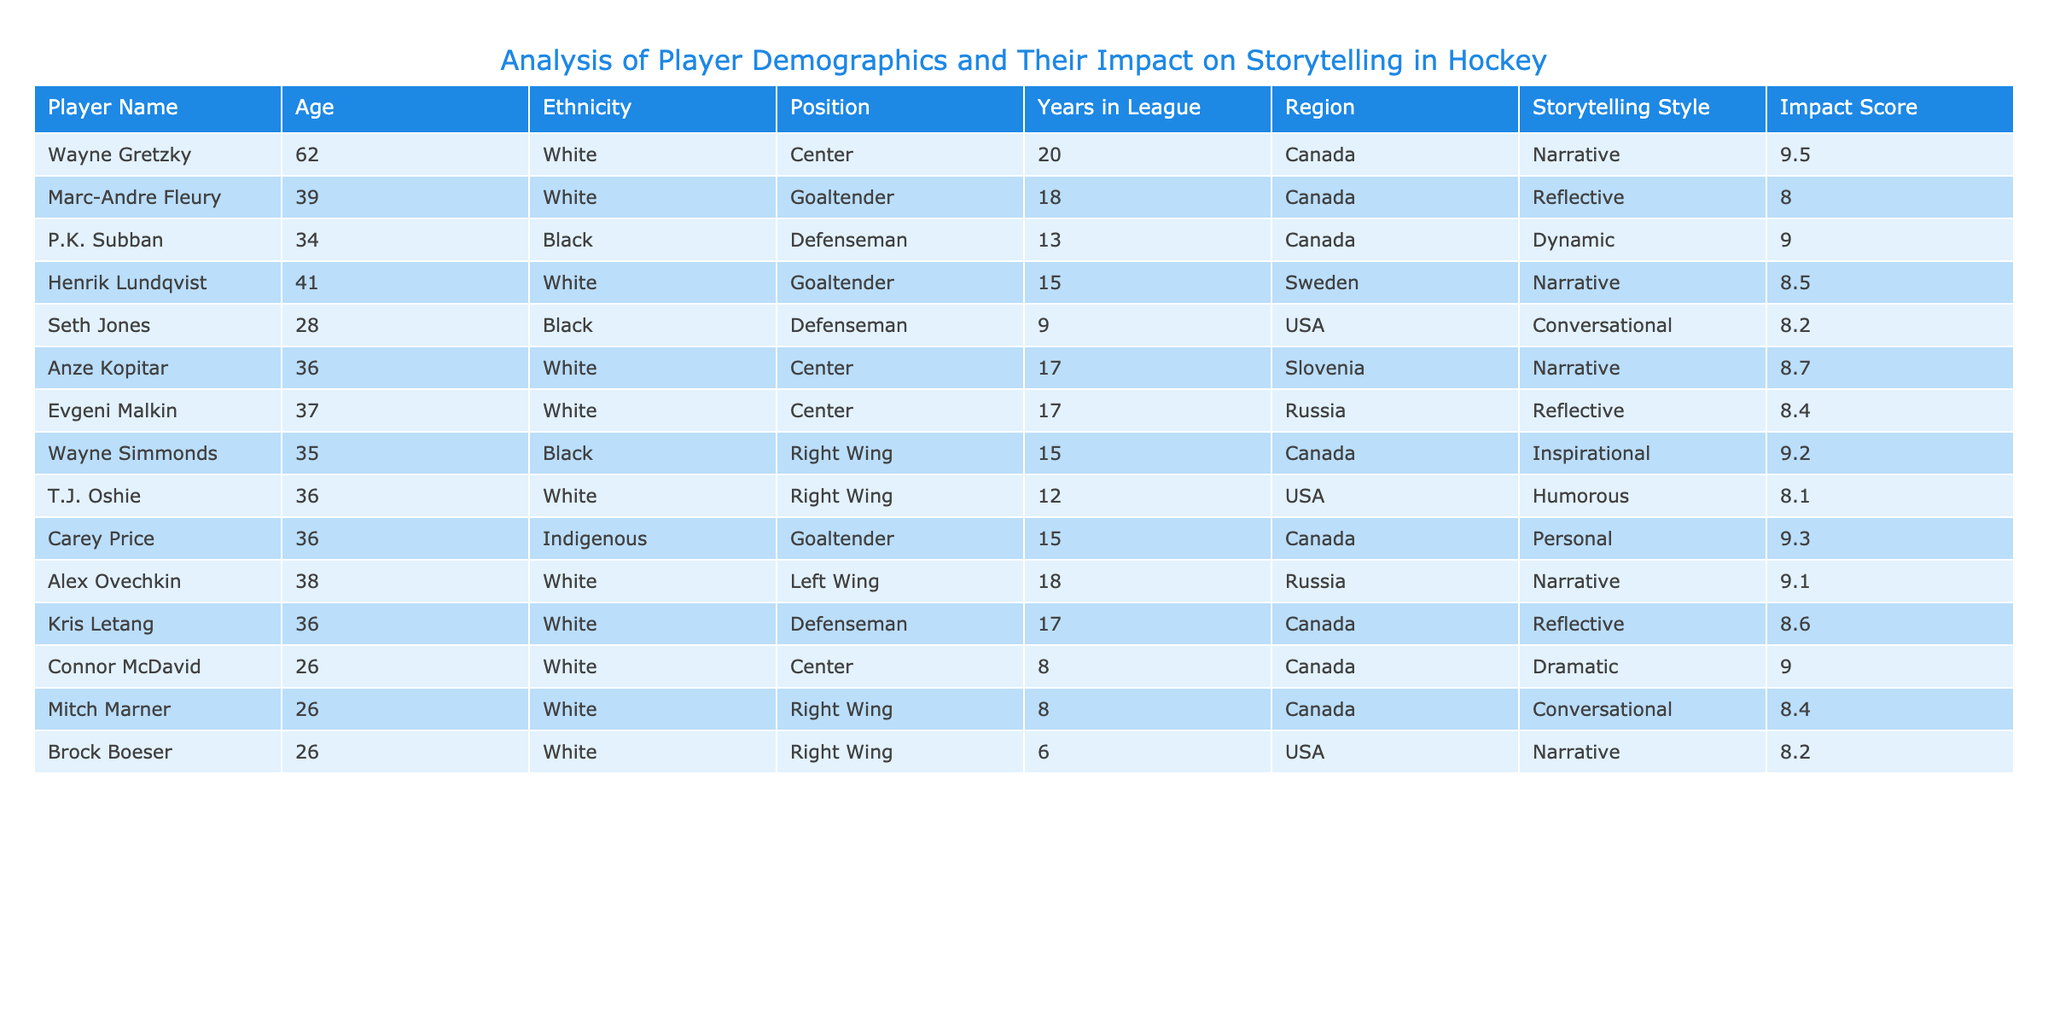What is the highest impact score among the players? By looking at the Impact Score column, we can see that Wayne Gretzky has the highest score at 9.5.
Answer: 9.5 How many players are in the league for more than 15 years? We can filter the Years in League column for values greater than 15. Players with 16 or more years are Wayne Gretzky, Marc-Andre Fleury, Henrik Lundqvist, Anze Kopitar, Evgeni Malkin, and Carey Price, totaling 6 players.
Answer: 6 What is the average age of players who have a Reflective storytelling style? The Reflective storytelling style includes three players: Marc-Andre Fleury (39), Evgeni Malkin (37), and Kris Letang (36). The sum of their ages is 39 + 37 + 36 = 112, and dividing by 3 gives an average age of 112/3 = 37.33.
Answer: 37.33 Are there any players from the USA with a Dynamic storytelling style? Looking at the table, we can see that Seth Jones from the USA has a Conversational storytelling style, and there is no player from the USA with a Dynamic style listed.
Answer: No Which demographic has the highest total impact score? To find this, we can group and sum impact scores by ethnicity. For White players the score is 9.5 + 8.0 + 8.5 + 8.7 + 8.4 + 9.1 + 8.6 = 61.8; for Black players it's 9.0 + 9.2 + 8.2 = 26.4; for the Indigenous player (Carey Price) it’s 9.3. The highest is White with 61.8.
Answer: White How many players with a Narrative storytelling style are there? We can look through the Storytelling Style column and count the instances of "Narrative." The players with this style are Wayne Gretzky, Anze Kopitar, Alex Ovechkin, and Brock Boeser, totaling 4 players.
Answer: 4 What is the age difference between the youngest and oldest players? The youngest player is Connor McDavid at 26 years old, and the oldest player is Wayne Gretzky at 62 years old. The difference in age is 62 - 26 = 36 years.
Answer: 36 Do all players with an Inspirational storytelling style belong to Canada? Checking the table, Wayne Simmonds is the only player with an Inspirational style and he is from Canada. Therefore, the statement is true.
Answer: Yes How many players positioned as Defenseman have an Impact Score greater than 8.0? From the table, the Defensemen are P.K. Subban (9.0), Seth Jones (8.2), and Kris Letang (8.6). All three have scores above 8.0, totaling 3 players.
Answer: 3 